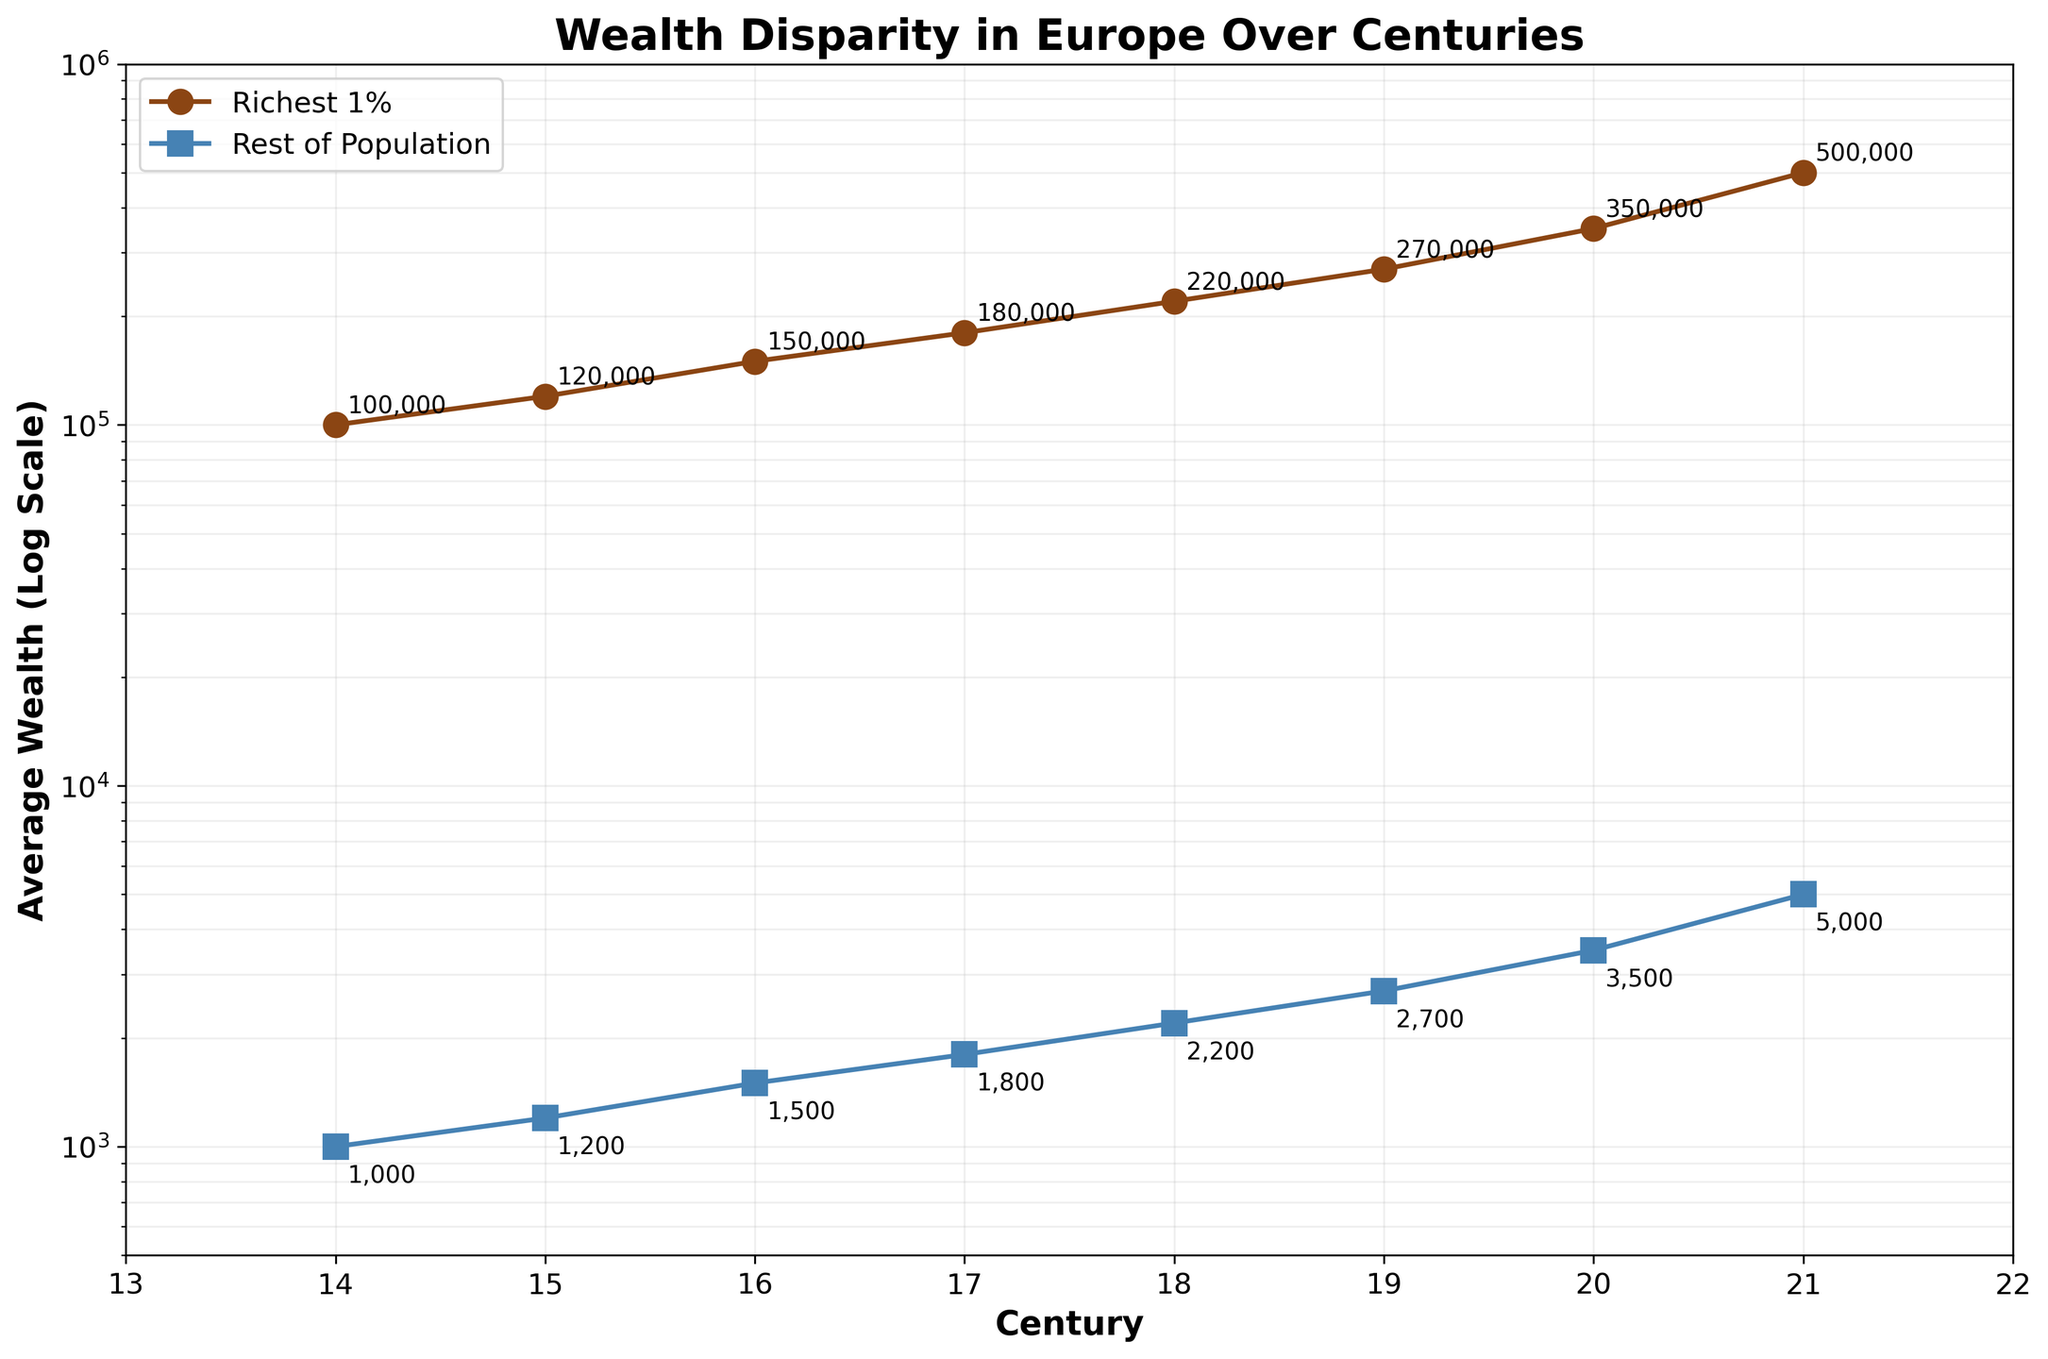What is the title of the plot? The title of a plot is usually located at the top and provides a summary of what the plot represents. In this plot, the title is clearly shown at the top.
Answer: Wealth Disparity in Europe Over Centuries What type of axis scale is used for the y-axis? By examining the y-axis, it becomes apparent that the values increase exponentially rather than linearly, indicating that a logarithmic scale is used.
Answer: Logarithmic scale Which century displayed the highest average wealth for the richest 1%? To determine this, look for the data point on the line representing the richest 1% with the highest y-value. This point appears in the 21st century.
Answer: 21st century What color is used to represent the rest of the population's average wealth? The plot uses different colors to represent different groups, with the rest of the population's average wealth displayed using the color blue.
Answer: Blue How does the wealth of the rest of the population compare to the wealth of the richest 1% in the 18th century? To compare, locate the data points for both groups in the 18th century and note their y-values. The richest 1% has a wealth of 220,000 while the rest have 2,200.
Answer: The richest 1% is wealthier by a factor of 100 What are the y-axis values for the 14th and 17th centuries for the richest 1%? First, find the data points for the 14th and 17th centuries on the curve representing the richest 1% and read off their y-axis values. These are 100,000 and 180,000, respectively.
Answer: 100,000 and 180,000 What is the difference in wealth between the richest 1% and the rest of the population in the 19th century? Find the data points for the 19th century for both groups. Subtract the wealth of the rest (2,700) from the wealth of the richest 1% (270,000).
Answer: 267,300 Calculate the percentage increase in wealth for the richest 1% from the 14th to the 21st century. Find the values for the 14th (100,000) and 21st (500,000) centuries. Use the formula ((New - Old) / Old) * 100 to find the percentage increase: ((500,000 - 100,000) / 100,000) * 100.
Answer: 400% By what factor did the wealth of the rest of the population increase from the 15th to the 20th century? Find the values for the 15th (1,200) and 20th (3,500) centuries. Calculate the factor by dividing the value in the 20th century by the value in the 15th century: 3,500 / 1,200.
Answer: Approximately 2.92 